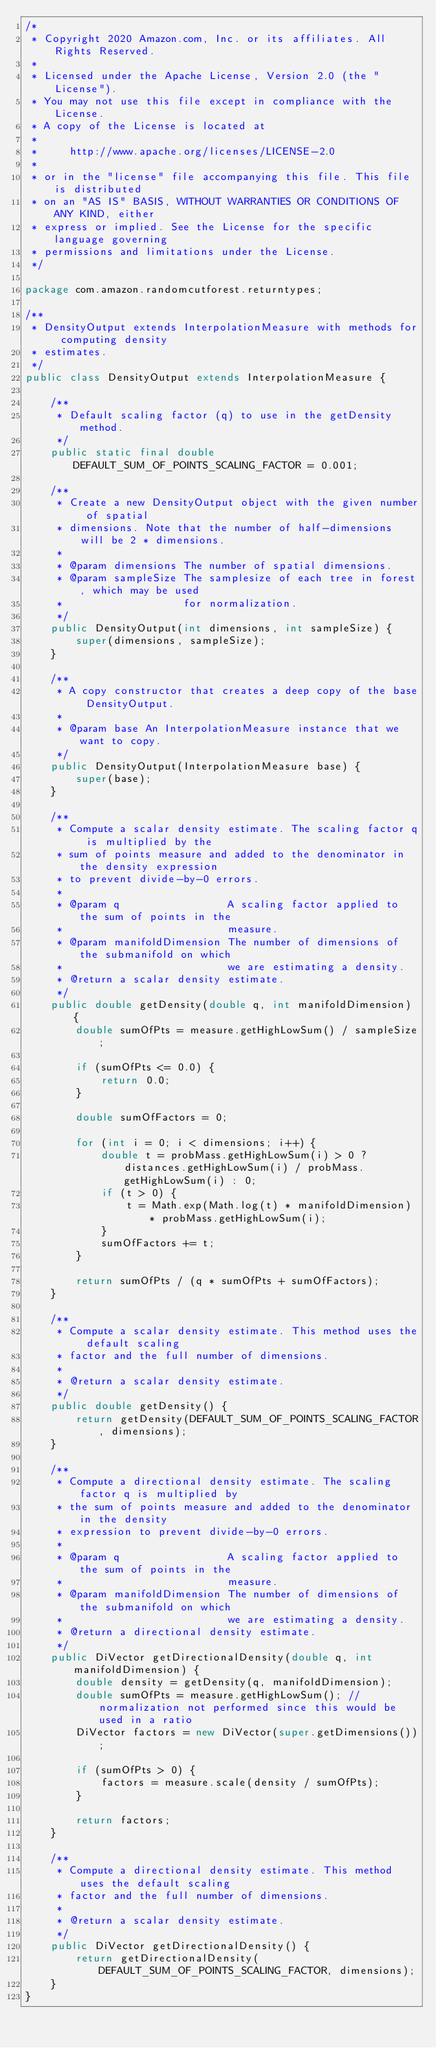Convert code to text. <code><loc_0><loc_0><loc_500><loc_500><_Java_>/*
 * Copyright 2020 Amazon.com, Inc. or its affiliates. All Rights Reserved.
 *
 * Licensed under the Apache License, Version 2.0 (the "License").
 * You may not use this file except in compliance with the License.
 * A copy of the License is located at
 *
 *     http://www.apache.org/licenses/LICENSE-2.0
 *
 * or in the "license" file accompanying this file. This file is distributed
 * on an "AS IS" BASIS, WITHOUT WARRANTIES OR CONDITIONS OF ANY KIND, either
 * express or implied. See the License for the specific language governing
 * permissions and limitations under the License.
 */

package com.amazon.randomcutforest.returntypes;

/**
 * DensityOutput extends InterpolationMeasure with methods for computing density
 * estimates.
 */
public class DensityOutput extends InterpolationMeasure {

    /**
     * Default scaling factor (q) to use in the getDensity method.
     */
    public static final double DEFAULT_SUM_OF_POINTS_SCALING_FACTOR = 0.001;

    /**
     * Create a new DensityOutput object with the given number of spatial
     * dimensions. Note that the number of half-dimensions will be 2 * dimensions.
     *
     * @param dimensions The number of spatial dimensions.
     * @param sampleSize The samplesize of each tree in forest, which may be used
     *                   for normalization.
     */
    public DensityOutput(int dimensions, int sampleSize) {
        super(dimensions, sampleSize);
    }

    /**
     * A copy constructor that creates a deep copy of the base DensityOutput.
     *
     * @param base An InterpolationMeasure instance that we want to copy.
     */
    public DensityOutput(InterpolationMeasure base) {
        super(base);
    }

    /**
     * Compute a scalar density estimate. The scaling factor q is multiplied by the
     * sum of points measure and added to the denominator in the density expression
     * to prevent divide-by-0 errors.
     *
     * @param q                 A scaling factor applied to the sum of points in the
     *                          measure.
     * @param manifoldDimension The number of dimensions of the submanifold on which
     *                          we are estimating a density.
     * @return a scalar density estimate.
     */
    public double getDensity(double q, int manifoldDimension) {
        double sumOfPts = measure.getHighLowSum() / sampleSize;

        if (sumOfPts <= 0.0) {
            return 0.0;
        }

        double sumOfFactors = 0;

        for (int i = 0; i < dimensions; i++) {
            double t = probMass.getHighLowSum(i) > 0 ? distances.getHighLowSum(i) / probMass.getHighLowSum(i) : 0;
            if (t > 0) {
                t = Math.exp(Math.log(t) * manifoldDimension) * probMass.getHighLowSum(i);
            }
            sumOfFactors += t;
        }

        return sumOfPts / (q * sumOfPts + sumOfFactors);
    }

    /**
     * Compute a scalar density estimate. This method uses the default scaling
     * factor and the full number of dimensions.
     *
     * @return a scalar density estimate.
     */
    public double getDensity() {
        return getDensity(DEFAULT_SUM_OF_POINTS_SCALING_FACTOR, dimensions);
    }

    /**
     * Compute a directional density estimate. The scaling factor q is multiplied by
     * the sum of points measure and added to the denominator in the density
     * expression to prevent divide-by-0 errors.
     *
     * @param q                 A scaling factor applied to the sum of points in the
     *                          measure.
     * @param manifoldDimension The number of dimensions of the submanifold on which
     *                          we are estimating a density.
     * @return a directional density estimate.
     */
    public DiVector getDirectionalDensity(double q, int manifoldDimension) {
        double density = getDensity(q, manifoldDimension);
        double sumOfPts = measure.getHighLowSum(); // normalization not performed since this would be used in a ratio
        DiVector factors = new DiVector(super.getDimensions());

        if (sumOfPts > 0) {
            factors = measure.scale(density / sumOfPts);
        }

        return factors;
    }

    /**
     * Compute a directional density estimate. This method uses the default scaling
     * factor and the full number of dimensions.
     *
     * @return a scalar density estimate.
     */
    public DiVector getDirectionalDensity() {
        return getDirectionalDensity(DEFAULT_SUM_OF_POINTS_SCALING_FACTOR, dimensions);
    }
}
</code> 